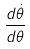Convert formula to latex. <formula><loc_0><loc_0><loc_500><loc_500>\frac { d \dot { \theta } } { d \theta }</formula> 